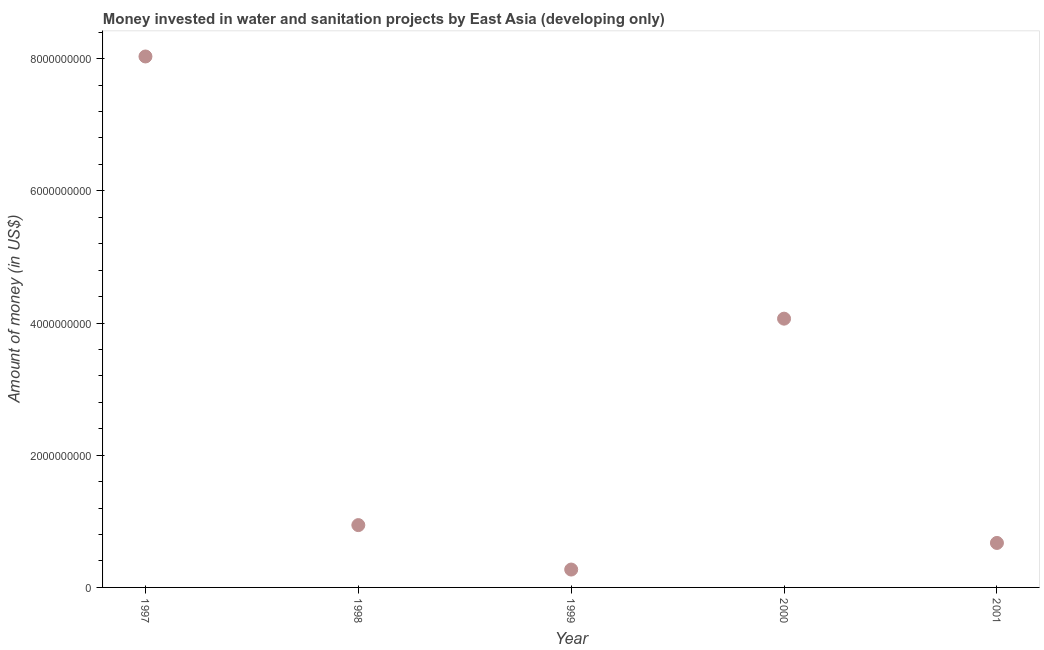What is the investment in 2001?
Your answer should be compact. 6.73e+08. Across all years, what is the maximum investment?
Provide a short and direct response. 8.03e+09. Across all years, what is the minimum investment?
Offer a very short reply. 2.70e+08. What is the sum of the investment?
Offer a terse response. 1.40e+1. What is the difference between the investment in 1998 and 1999?
Your answer should be very brief. 6.72e+08. What is the average investment per year?
Ensure brevity in your answer.  2.80e+09. What is the median investment?
Your answer should be very brief. 9.43e+08. In how many years, is the investment greater than 4800000000 US$?
Provide a short and direct response. 1. Do a majority of the years between 1999 and 1997 (inclusive) have investment greater than 6000000000 US$?
Provide a short and direct response. No. What is the ratio of the investment in 1998 to that in 2000?
Offer a very short reply. 0.23. Is the difference between the investment in 1998 and 2001 greater than the difference between any two years?
Your answer should be very brief. No. What is the difference between the highest and the second highest investment?
Provide a succinct answer. 3.97e+09. Is the sum of the investment in 1999 and 2000 greater than the maximum investment across all years?
Offer a very short reply. No. What is the difference between the highest and the lowest investment?
Your response must be concise. 7.76e+09. Does the investment monotonically increase over the years?
Give a very brief answer. No. What is the title of the graph?
Ensure brevity in your answer.  Money invested in water and sanitation projects by East Asia (developing only). What is the label or title of the X-axis?
Offer a very short reply. Year. What is the label or title of the Y-axis?
Keep it short and to the point. Amount of money (in US$). What is the Amount of money (in US$) in 1997?
Keep it short and to the point. 8.03e+09. What is the Amount of money (in US$) in 1998?
Ensure brevity in your answer.  9.43e+08. What is the Amount of money (in US$) in 1999?
Ensure brevity in your answer.  2.70e+08. What is the Amount of money (in US$) in 2000?
Keep it short and to the point. 4.07e+09. What is the Amount of money (in US$) in 2001?
Keep it short and to the point. 6.73e+08. What is the difference between the Amount of money (in US$) in 1997 and 1998?
Make the answer very short. 7.09e+09. What is the difference between the Amount of money (in US$) in 1997 and 1999?
Provide a short and direct response. 7.76e+09. What is the difference between the Amount of money (in US$) in 1997 and 2000?
Ensure brevity in your answer.  3.97e+09. What is the difference between the Amount of money (in US$) in 1997 and 2001?
Offer a terse response. 7.36e+09. What is the difference between the Amount of money (in US$) in 1998 and 1999?
Offer a very short reply. 6.72e+08. What is the difference between the Amount of money (in US$) in 1998 and 2000?
Make the answer very short. -3.12e+09. What is the difference between the Amount of money (in US$) in 1998 and 2001?
Make the answer very short. 2.70e+08. What is the difference between the Amount of money (in US$) in 1999 and 2000?
Give a very brief answer. -3.80e+09. What is the difference between the Amount of money (in US$) in 1999 and 2001?
Your answer should be compact. -4.02e+08. What is the difference between the Amount of money (in US$) in 2000 and 2001?
Make the answer very short. 3.39e+09. What is the ratio of the Amount of money (in US$) in 1997 to that in 1998?
Keep it short and to the point. 8.52. What is the ratio of the Amount of money (in US$) in 1997 to that in 1999?
Offer a terse response. 29.7. What is the ratio of the Amount of money (in US$) in 1997 to that in 2000?
Give a very brief answer. 1.98. What is the ratio of the Amount of money (in US$) in 1997 to that in 2001?
Offer a terse response. 11.94. What is the ratio of the Amount of money (in US$) in 1998 to that in 1999?
Ensure brevity in your answer.  3.48. What is the ratio of the Amount of money (in US$) in 1998 to that in 2000?
Provide a succinct answer. 0.23. What is the ratio of the Amount of money (in US$) in 1998 to that in 2001?
Make the answer very short. 1.4. What is the ratio of the Amount of money (in US$) in 1999 to that in 2000?
Make the answer very short. 0.07. What is the ratio of the Amount of money (in US$) in 1999 to that in 2001?
Give a very brief answer. 0.4. What is the ratio of the Amount of money (in US$) in 2000 to that in 2001?
Provide a succinct answer. 6.04. 